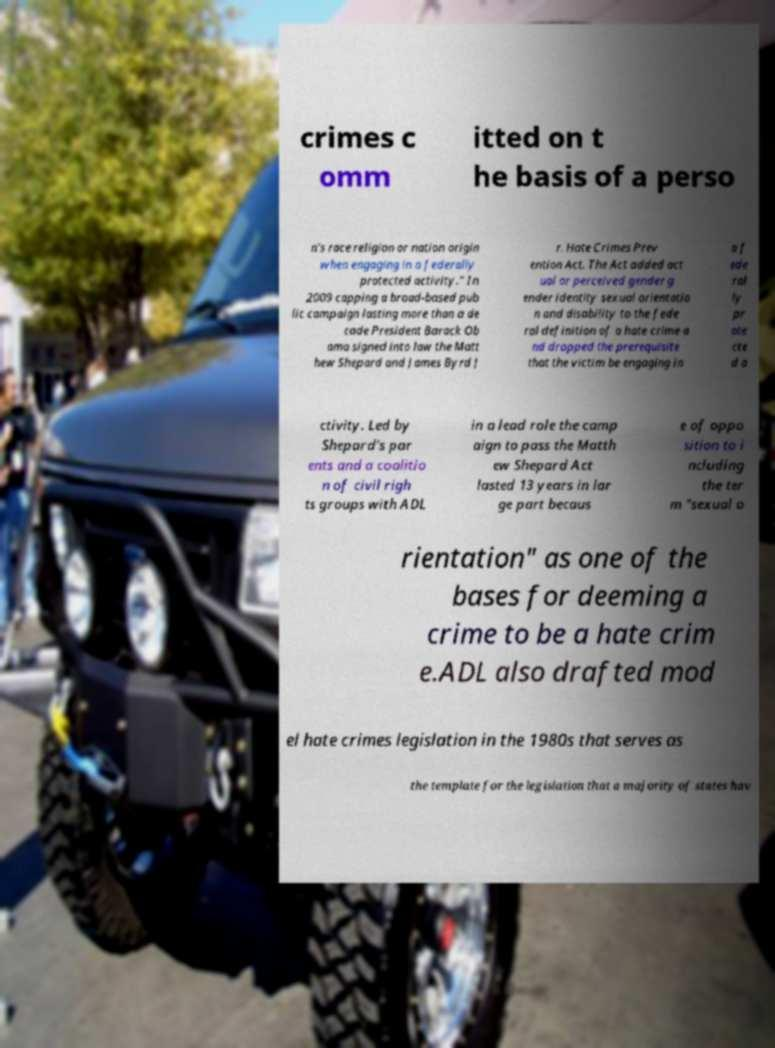Please identify and transcribe the text found in this image. crimes c omm itted on t he basis of a perso n's race religion or nation origin when engaging in a federally protected activity." In 2009 capping a broad-based pub lic campaign lasting more than a de cade President Barack Ob ama signed into law the Matt hew Shepard and James Byrd J r. Hate Crimes Prev ention Act. The Act added act ual or perceived gender g ender identity sexual orientatio n and disability to the fede ral definition of a hate crime a nd dropped the prerequisite that the victim be engaging in a f ede ral ly pr ote cte d a ctivity. Led by Shepard's par ents and a coalitio n of civil righ ts groups with ADL in a lead role the camp aign to pass the Matth ew Shepard Act lasted 13 years in lar ge part becaus e of oppo sition to i ncluding the ter m "sexual o rientation" as one of the bases for deeming a crime to be a hate crim e.ADL also drafted mod el hate crimes legislation in the 1980s that serves as the template for the legislation that a majority of states hav 